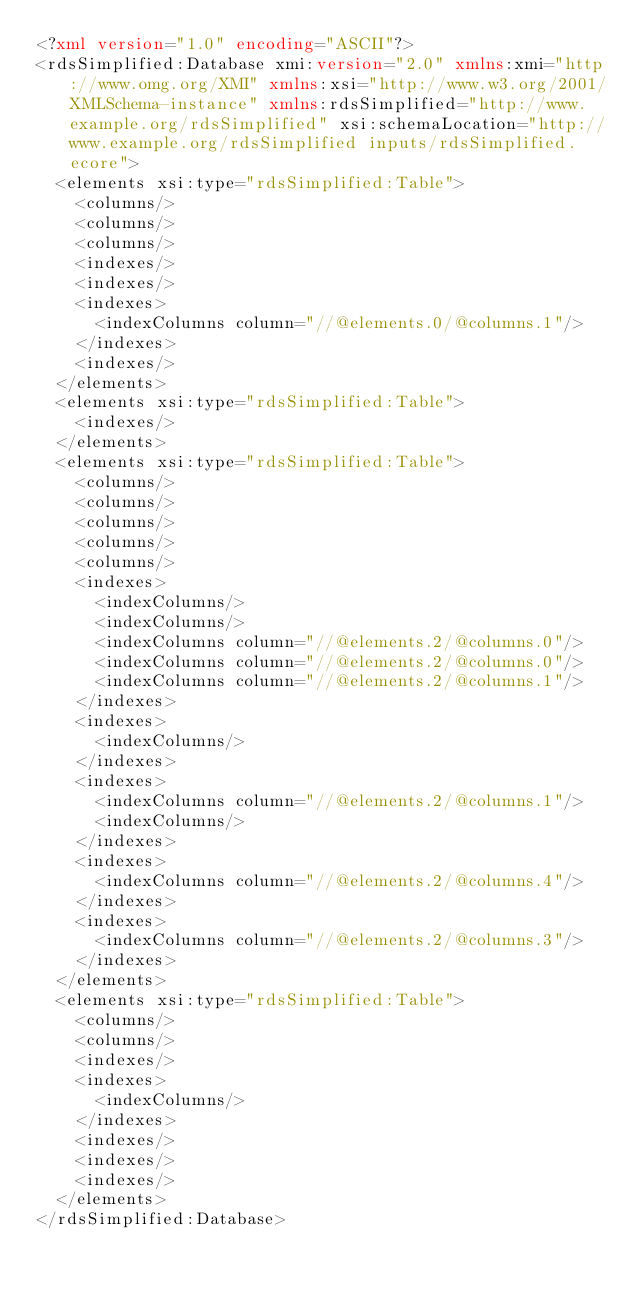Convert code to text. <code><loc_0><loc_0><loc_500><loc_500><_XML_><?xml version="1.0" encoding="ASCII"?>
<rdsSimplified:Database xmi:version="2.0" xmlns:xmi="http://www.omg.org/XMI" xmlns:xsi="http://www.w3.org/2001/XMLSchema-instance" xmlns:rdsSimplified="http://www.example.org/rdsSimplified" xsi:schemaLocation="http://www.example.org/rdsSimplified inputs/rdsSimplified.ecore">
  <elements xsi:type="rdsSimplified:Table">
    <columns/>
    <columns/>
    <columns/>
    <indexes/>
    <indexes/>
    <indexes>
      <indexColumns column="//@elements.0/@columns.1"/>
    </indexes>
    <indexes/>
  </elements>
  <elements xsi:type="rdsSimplified:Table">
    <indexes/>
  </elements>
  <elements xsi:type="rdsSimplified:Table">
    <columns/>
    <columns/>
    <columns/>
    <columns/>
    <columns/>
    <indexes>
      <indexColumns/>
      <indexColumns/>
      <indexColumns column="//@elements.2/@columns.0"/>
      <indexColumns column="//@elements.2/@columns.0"/>
      <indexColumns column="//@elements.2/@columns.1"/>
    </indexes>
    <indexes>
      <indexColumns/>
    </indexes>
    <indexes>
      <indexColumns column="//@elements.2/@columns.1"/>
      <indexColumns/>
    </indexes>
    <indexes>
      <indexColumns column="//@elements.2/@columns.4"/>
    </indexes>
    <indexes>
      <indexColumns column="//@elements.2/@columns.3"/>
    </indexes>
  </elements>
  <elements xsi:type="rdsSimplified:Table">
    <columns/>
    <columns/>
    <indexes/>
    <indexes>
      <indexColumns/>
    </indexes>
    <indexes/>
    <indexes/>
    <indexes/>
  </elements>
</rdsSimplified:Database>
</code> 